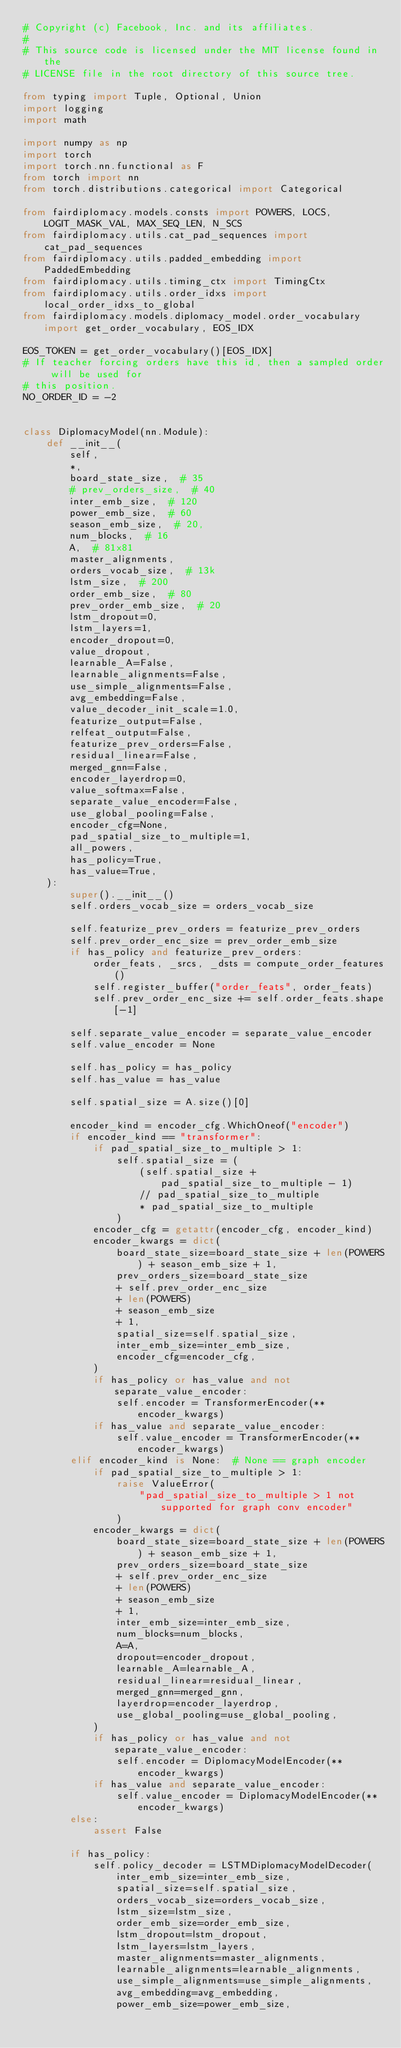<code> <loc_0><loc_0><loc_500><loc_500><_Python_># Copyright (c) Facebook, Inc. and its affiliates.
#
# This source code is licensed under the MIT license found in the
# LICENSE file in the root directory of this source tree.

from typing import Tuple, Optional, Union
import logging
import math

import numpy as np
import torch
import torch.nn.functional as F
from torch import nn
from torch.distributions.categorical import Categorical

from fairdiplomacy.models.consts import POWERS, LOCS, LOGIT_MASK_VAL, MAX_SEQ_LEN, N_SCS
from fairdiplomacy.utils.cat_pad_sequences import cat_pad_sequences
from fairdiplomacy.utils.padded_embedding import PaddedEmbedding
from fairdiplomacy.utils.timing_ctx import TimingCtx
from fairdiplomacy.utils.order_idxs import local_order_idxs_to_global
from fairdiplomacy.models.diplomacy_model.order_vocabulary import get_order_vocabulary, EOS_IDX

EOS_TOKEN = get_order_vocabulary()[EOS_IDX]
# If teacher forcing orders have this id, then a sampled order will be used for
# this position.
NO_ORDER_ID = -2


class DiplomacyModel(nn.Module):
    def __init__(
        self,
        *,
        board_state_size,  # 35
        # prev_orders_size,  # 40
        inter_emb_size,  # 120
        power_emb_size,  # 60
        season_emb_size,  # 20,
        num_blocks,  # 16
        A,  # 81x81
        master_alignments,
        orders_vocab_size,  # 13k
        lstm_size,  # 200
        order_emb_size,  # 80
        prev_order_emb_size,  # 20
        lstm_dropout=0,
        lstm_layers=1,
        encoder_dropout=0,
        value_dropout,
        learnable_A=False,
        learnable_alignments=False,
        use_simple_alignments=False,
        avg_embedding=False,
        value_decoder_init_scale=1.0,
        featurize_output=False,
        relfeat_output=False,
        featurize_prev_orders=False,
        residual_linear=False,
        merged_gnn=False,
        encoder_layerdrop=0,
        value_softmax=False,
        separate_value_encoder=False,
        use_global_pooling=False,
        encoder_cfg=None,
        pad_spatial_size_to_multiple=1,
        all_powers,
        has_policy=True,
        has_value=True,
    ):
        super().__init__()
        self.orders_vocab_size = orders_vocab_size

        self.featurize_prev_orders = featurize_prev_orders
        self.prev_order_enc_size = prev_order_emb_size
        if has_policy and featurize_prev_orders:
            order_feats, _srcs, _dsts = compute_order_features()
            self.register_buffer("order_feats", order_feats)
            self.prev_order_enc_size += self.order_feats.shape[-1]

        self.separate_value_encoder = separate_value_encoder
        self.value_encoder = None

        self.has_policy = has_policy
        self.has_value = has_value

        self.spatial_size = A.size()[0]

        encoder_kind = encoder_cfg.WhichOneof("encoder")
        if encoder_kind == "transformer":
            if pad_spatial_size_to_multiple > 1:
                self.spatial_size = (
                    (self.spatial_size + pad_spatial_size_to_multiple - 1)
                    // pad_spatial_size_to_multiple
                    * pad_spatial_size_to_multiple
                )
            encoder_cfg = getattr(encoder_cfg, encoder_kind)
            encoder_kwargs = dict(
                board_state_size=board_state_size + len(POWERS) + season_emb_size + 1,
                prev_orders_size=board_state_size
                + self.prev_order_enc_size
                + len(POWERS)
                + season_emb_size
                + 1,
                spatial_size=self.spatial_size,
                inter_emb_size=inter_emb_size,
                encoder_cfg=encoder_cfg,
            )
            if has_policy or has_value and not separate_value_encoder:
                self.encoder = TransformerEncoder(**encoder_kwargs)
            if has_value and separate_value_encoder:
                self.value_encoder = TransformerEncoder(**encoder_kwargs)
        elif encoder_kind is None:  # None == graph encoder
            if pad_spatial_size_to_multiple > 1:
                raise ValueError(
                    "pad_spatial_size_to_multiple > 1 not supported for graph conv encoder"
                )
            encoder_kwargs = dict(
                board_state_size=board_state_size + len(POWERS) + season_emb_size + 1,
                prev_orders_size=board_state_size
                + self.prev_order_enc_size
                + len(POWERS)
                + season_emb_size
                + 1,
                inter_emb_size=inter_emb_size,
                num_blocks=num_blocks,
                A=A,
                dropout=encoder_dropout,
                learnable_A=learnable_A,
                residual_linear=residual_linear,
                merged_gnn=merged_gnn,
                layerdrop=encoder_layerdrop,
                use_global_pooling=use_global_pooling,
            )
            if has_policy or has_value and not separate_value_encoder:
                self.encoder = DiplomacyModelEncoder(**encoder_kwargs)
            if has_value and separate_value_encoder:
                self.value_encoder = DiplomacyModelEncoder(**encoder_kwargs)
        else:
            assert False

        if has_policy:
            self.policy_decoder = LSTMDiplomacyModelDecoder(
                inter_emb_size=inter_emb_size,
                spatial_size=self.spatial_size,
                orders_vocab_size=orders_vocab_size,
                lstm_size=lstm_size,
                order_emb_size=order_emb_size,
                lstm_dropout=lstm_dropout,
                lstm_layers=lstm_layers,
                master_alignments=master_alignments,
                learnable_alignments=learnable_alignments,
                use_simple_alignments=use_simple_alignments,
                avg_embedding=avg_embedding,
                power_emb_size=power_emb_size,</code> 